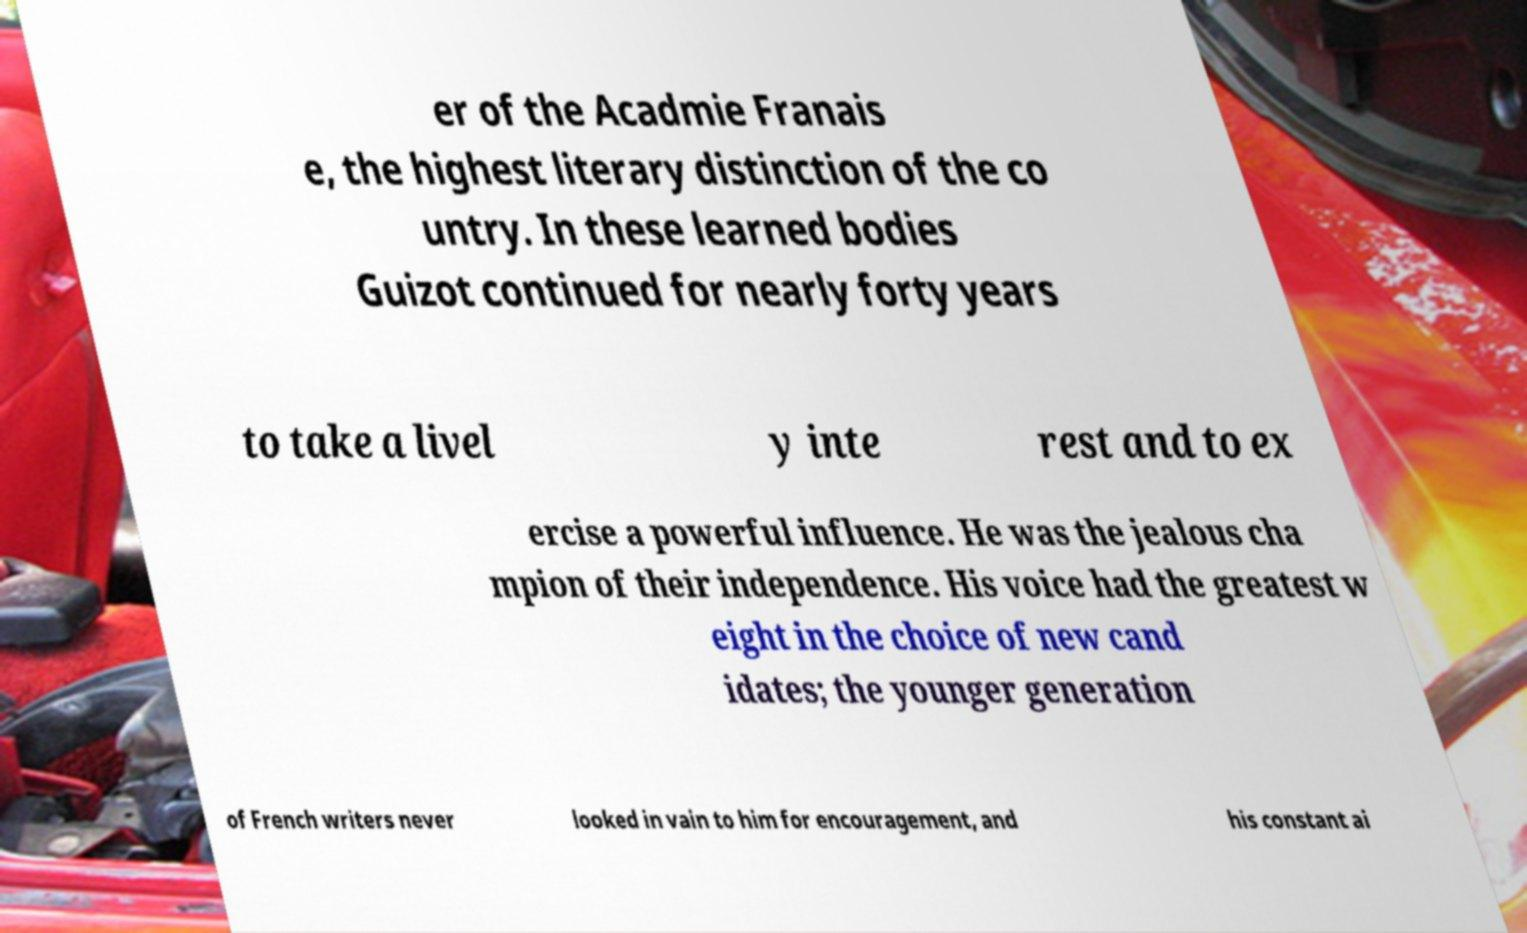Could you extract and type out the text from this image? er of the Acadmie Franais e, the highest literary distinction of the co untry. In these learned bodies Guizot continued for nearly forty years to take a livel y inte rest and to ex ercise a powerful influence. He was the jealous cha mpion of their independence. His voice had the greatest w eight in the choice of new cand idates; the younger generation of French writers never looked in vain to him for encouragement, and his constant ai 